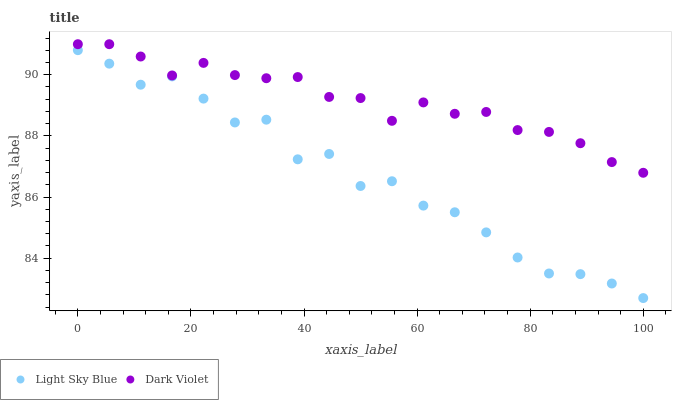Does Light Sky Blue have the minimum area under the curve?
Answer yes or no. Yes. Does Dark Violet have the maximum area under the curve?
Answer yes or no. Yes. Does Dark Violet have the minimum area under the curve?
Answer yes or no. No. Is Dark Violet the smoothest?
Answer yes or no. Yes. Is Light Sky Blue the roughest?
Answer yes or no. Yes. Is Dark Violet the roughest?
Answer yes or no. No. Does Light Sky Blue have the lowest value?
Answer yes or no. Yes. Does Dark Violet have the lowest value?
Answer yes or no. No. Does Dark Violet have the highest value?
Answer yes or no. Yes. Is Light Sky Blue less than Dark Violet?
Answer yes or no. Yes. Is Dark Violet greater than Light Sky Blue?
Answer yes or no. Yes. Does Light Sky Blue intersect Dark Violet?
Answer yes or no. No. 